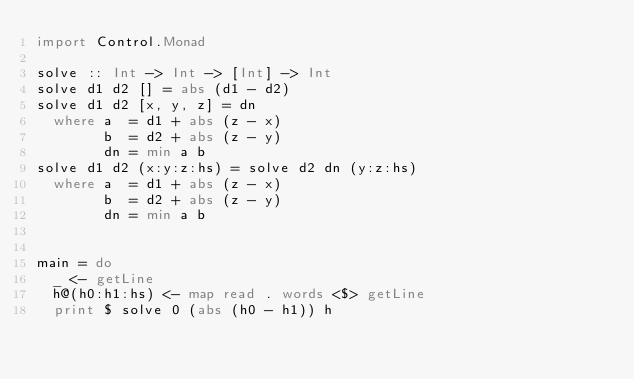Convert code to text. <code><loc_0><loc_0><loc_500><loc_500><_Haskell_>import Control.Monad

solve :: Int -> Int -> [Int] -> Int
solve d1 d2 [] = abs (d1 - d2)
solve d1 d2 [x, y, z] = dn
  where a  = d1 + abs (z - x)
        b  = d2 + abs (z - y)
        dn = min a b
solve d1 d2 (x:y:z:hs) = solve d2 dn (y:z:hs)
  where a  = d1 + abs (z - x)
        b  = d2 + abs (z - y)
        dn = min a b


main = do
  _ <- getLine
  h@(h0:h1:hs) <- map read . words <$> getLine
  print $ solve 0 (abs (h0 - h1)) h
</code> 